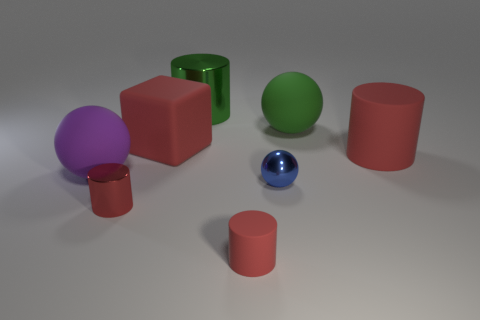What color is the small rubber thing that is the same shape as the red metallic object?
Provide a succinct answer. Red. There is a red object that is both behind the tiny red rubber thing and on the right side of the big green metal cylinder; what material is it?
Ensure brevity in your answer.  Rubber. There is a green object that is left of the green sphere; is its size the same as the metal ball?
Your answer should be very brief. No. What is the material of the tiny ball?
Give a very brief answer. Metal. There is a rubber block that is behind the blue object; what is its color?
Your answer should be compact. Red. How many big things are either green shiny objects or red shiny things?
Offer a very short reply. 1. Do the rubber cylinder on the left side of the tiny ball and the shiny thing that is behind the big purple rubber object have the same color?
Your answer should be compact. No. What number of other objects are there of the same color as the matte block?
Your answer should be very brief. 3. How many purple objects are large blocks or large spheres?
Keep it short and to the point. 1. There is a small rubber thing; is its shape the same as the tiny metallic thing left of the small matte object?
Provide a succinct answer. Yes. 